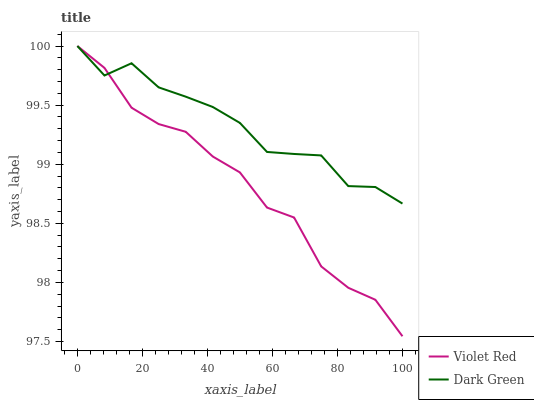Does Violet Red have the minimum area under the curve?
Answer yes or no. Yes. Does Dark Green have the maximum area under the curve?
Answer yes or no. Yes. Does Dark Green have the minimum area under the curve?
Answer yes or no. No. Is Dark Green the smoothest?
Answer yes or no. Yes. Is Violet Red the roughest?
Answer yes or no. Yes. Is Dark Green the roughest?
Answer yes or no. No. Does Violet Red have the lowest value?
Answer yes or no. Yes. Does Dark Green have the lowest value?
Answer yes or no. No. Does Dark Green have the highest value?
Answer yes or no. Yes. Does Violet Red intersect Dark Green?
Answer yes or no. Yes. Is Violet Red less than Dark Green?
Answer yes or no. No. Is Violet Red greater than Dark Green?
Answer yes or no. No. 